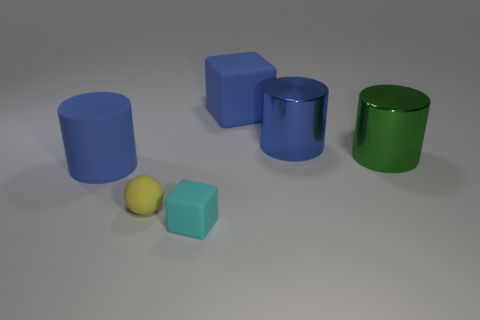What color is the tiny matte thing that is to the left of the tiny cyan matte object?
Provide a succinct answer. Yellow. What number of objects are small rubber things in front of the tiny rubber ball or blocks that are in front of the blue metal cylinder?
Provide a succinct answer. 1. What number of large brown matte objects have the same shape as the large blue metallic thing?
Your response must be concise. 0. What color is the matte cylinder that is the same size as the blue metallic cylinder?
Your response must be concise. Blue. What is the color of the cube in front of the cylinder to the left of the block behind the small rubber block?
Your answer should be compact. Cyan. Do the rubber cylinder and the shiny thing to the left of the green metallic cylinder have the same size?
Your answer should be compact. Yes. What number of things are either blue cylinders or tiny purple rubber cylinders?
Make the answer very short. 2. Is there a big blue block that has the same material as the small ball?
Give a very brief answer. Yes. What size is the shiny object that is the same color as the large matte cube?
Your answer should be compact. Large. There is a big rubber thing on the left side of the matte object that is in front of the yellow matte ball; what is its color?
Your answer should be very brief. Blue. 